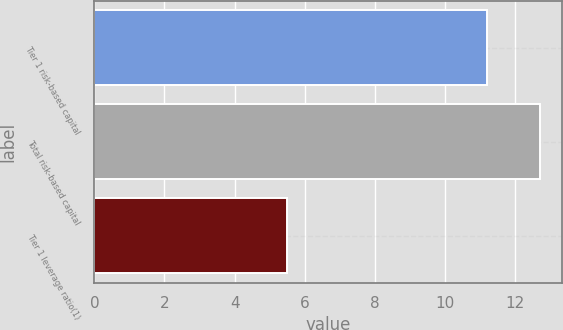Convert chart to OTSL. <chart><loc_0><loc_0><loc_500><loc_500><bar_chart><fcel>Tier 1 risk-based capital<fcel>Total risk-based capital<fcel>Tier 1 leverage ratio(1)<nl><fcel>11.2<fcel>12.7<fcel>5.5<nl></chart> 